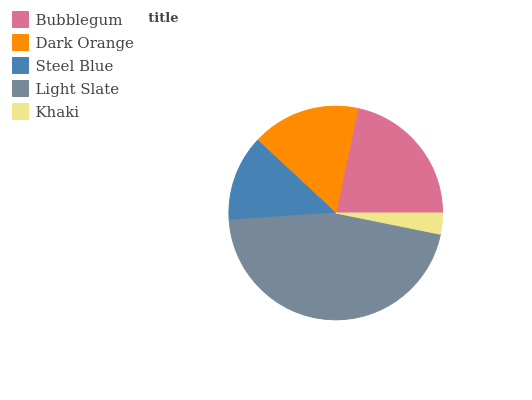Is Khaki the minimum?
Answer yes or no. Yes. Is Light Slate the maximum?
Answer yes or no. Yes. Is Dark Orange the minimum?
Answer yes or no. No. Is Dark Orange the maximum?
Answer yes or no. No. Is Bubblegum greater than Dark Orange?
Answer yes or no. Yes. Is Dark Orange less than Bubblegum?
Answer yes or no. Yes. Is Dark Orange greater than Bubblegum?
Answer yes or no. No. Is Bubblegum less than Dark Orange?
Answer yes or no. No. Is Dark Orange the high median?
Answer yes or no. Yes. Is Dark Orange the low median?
Answer yes or no. Yes. Is Steel Blue the high median?
Answer yes or no. No. Is Bubblegum the low median?
Answer yes or no. No. 